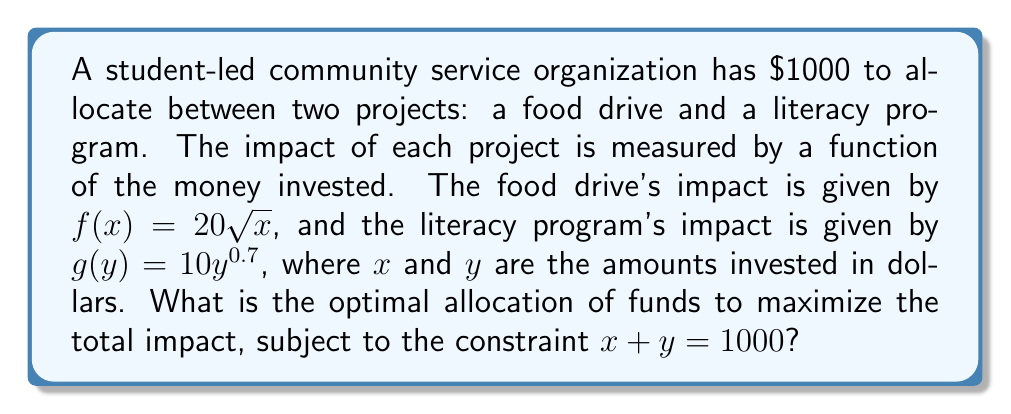Can you solve this math problem? To solve this optimization problem, we'll use the method of Lagrange multipliers:

1) Let's define the function to maximize:
   $h(x,y) = f(x) + g(y) = 20\sqrt{x} + 10y^{0.7}$

2) The constraint is:
   $g(x,y) = x + y - 1000 = 0$

3) Form the Lagrangian:
   $L(x,y,\lambda) = 20\sqrt{x} + 10y^{0.7} + \lambda(x + y - 1000)$

4) Set partial derivatives to zero:
   $$\frac{\partial L}{\partial x} = \frac{10}{\sqrt{x}} + \lambda = 0$$
   $$\frac{\partial L}{\partial y} = 7y^{-0.3} + \lambda = 0$$
   $$\frac{\partial L}{\partial \lambda} = x + y - 1000 = 0$$

5) From the first two equations:
   $$\frac{10}{\sqrt{x}} = 7y^{-0.3}$$

6) Simplify:
   $$\frac{100}{x} = \frac{49}{y^{0.6}}$$
   $$100y^{0.6} = 49x$$
   $$y^{0.6} = 0.49x$$
   $$y = (0.49x)^{\frac{5}{3}} \approx 0.2269x^{\frac{5}{3}}$$

7) Substitute into the constraint:
   $$x + 0.2269x^{\frac{5}{3}} = 1000$$

8) Solve numerically (using a computer or calculator):
   $x \approx 641.03$
   $y \approx 358.97$

9) Round to the nearest dollar:
   $x = 641$ (food drive)
   $y = 359$ (literacy program)
Answer: $641 to food drive, $359 to literacy program 